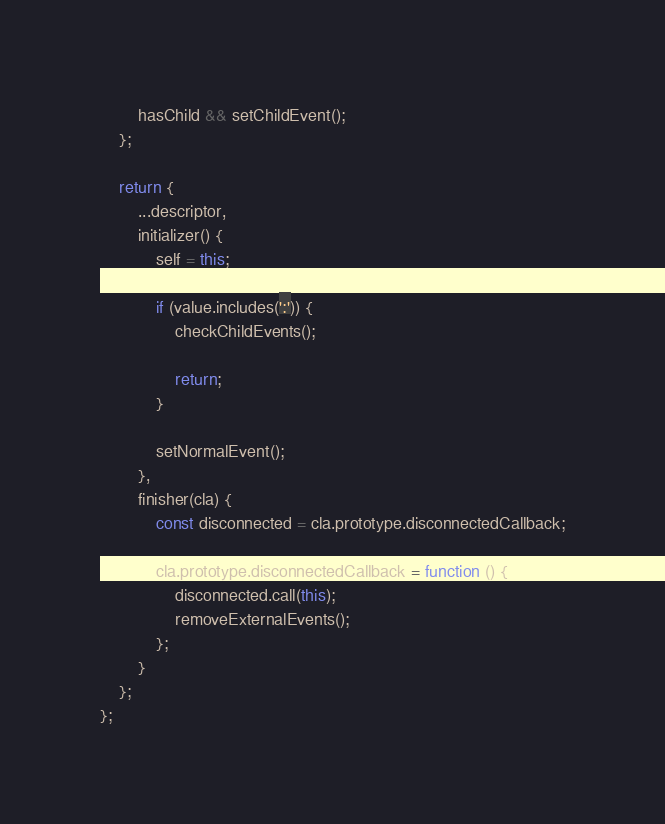<code> <loc_0><loc_0><loc_500><loc_500><_JavaScript_>		hasChild && setChildEvent();
	};

	return {
		...descriptor,
		initializer() {
			self = this;

			if (value.includes(':')) {
				checkChildEvents();

				return;
			}

			setNormalEvent();
		},
		finisher(cla) {
			const disconnected = cla.prototype.disconnectedCallback;

			cla.prototype.disconnectedCallback = function () {
				disconnected.call(this);
				removeExternalEvents();
			};
		}
	};
};
</code> 